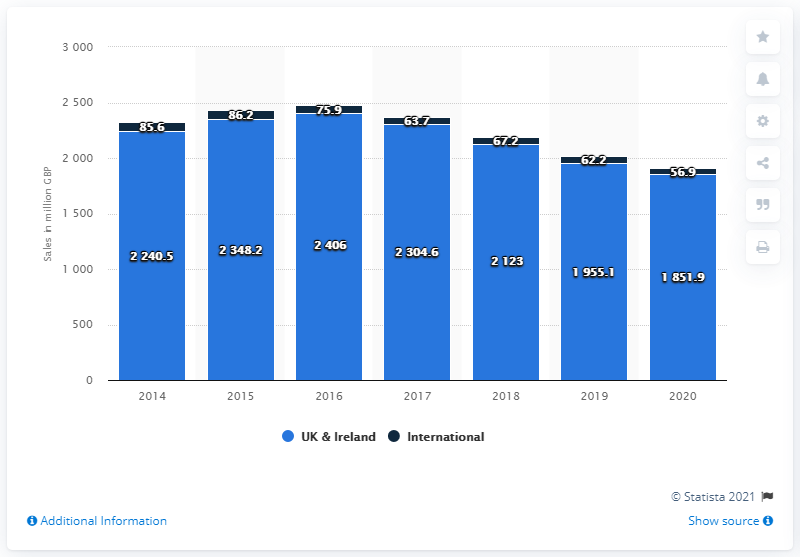Highlight a few significant elements in this photo. Next plc generated 1851.9 million British pounds through its UK and Ireland stores in the year ended January 2020. 